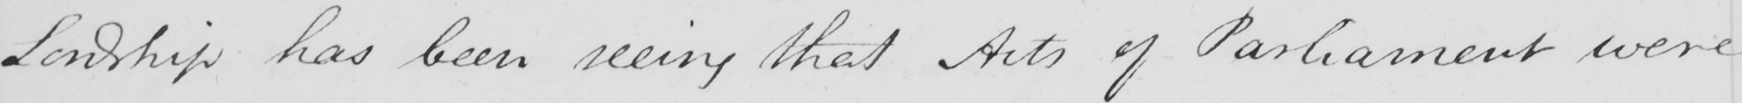What does this handwritten line say? Lordship has been seeing that Acts of Parliament were 